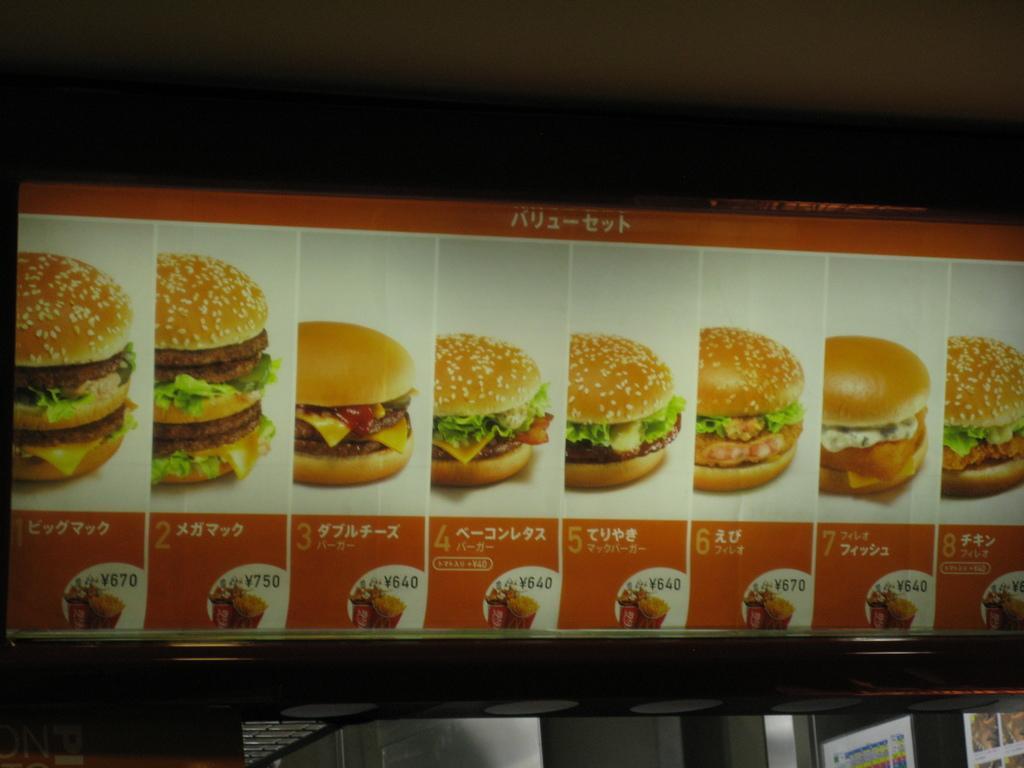Can you describe this image briefly? In this image there is a poster having the images of burgers. Below it there is price edited on the poster. Bottom of the image few posters are attached to the wall. 